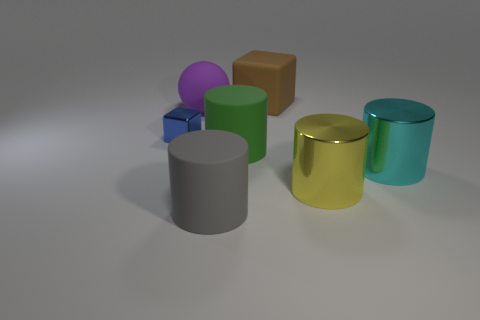Add 2 purple matte spheres. How many objects exist? 9 Subtract all cylinders. How many objects are left? 3 Add 6 big matte cylinders. How many big matte cylinders exist? 8 Subtract 1 green cylinders. How many objects are left? 6 Subtract all gray matte objects. Subtract all shiny objects. How many objects are left? 3 Add 5 brown blocks. How many brown blocks are left? 6 